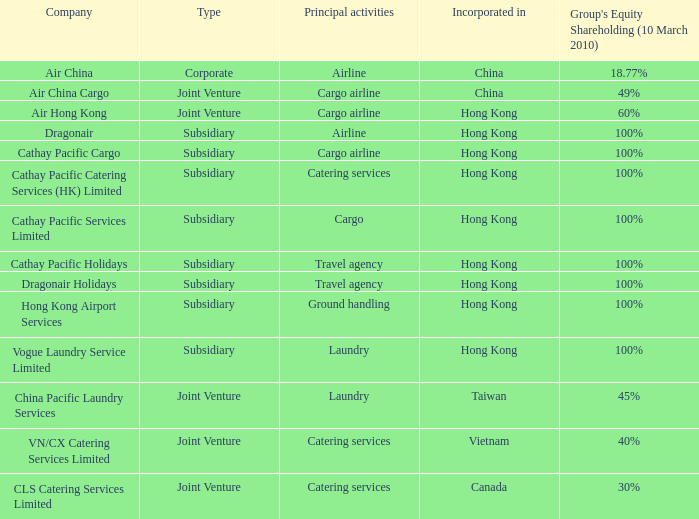Which  company's type is joint venture, and has principle activities listed as Cargo Airline and an incorporation of China? Air China Cargo. Parse the table in full. {'header': ['Company', 'Type', 'Principal activities', 'Incorporated in', "Group's Equity Shareholding (10 March 2010)"], 'rows': [['Air China', 'Corporate', 'Airline', 'China', '18.77%'], ['Air China Cargo', 'Joint Venture', 'Cargo airline', 'China', '49%'], ['Air Hong Kong', 'Joint Venture', 'Cargo airline', 'Hong Kong', '60%'], ['Dragonair', 'Subsidiary', 'Airline', 'Hong Kong', '100%'], ['Cathay Pacific Cargo', 'Subsidiary', 'Cargo airline', 'Hong Kong', '100%'], ['Cathay Pacific Catering Services (HK) Limited', 'Subsidiary', 'Catering services', 'Hong Kong', '100%'], ['Cathay Pacific Services Limited', 'Subsidiary', 'Cargo', 'Hong Kong', '100%'], ['Cathay Pacific Holidays', 'Subsidiary', 'Travel agency', 'Hong Kong', '100%'], ['Dragonair Holidays', 'Subsidiary', 'Travel agency', 'Hong Kong', '100%'], ['Hong Kong Airport Services', 'Subsidiary', 'Ground handling', 'Hong Kong', '100%'], ['Vogue Laundry Service Limited', 'Subsidiary', 'Laundry', 'Hong Kong', '100%'], ['China Pacific Laundry Services', 'Joint Venture', 'Laundry', 'Taiwan', '45%'], ['VN/CX Catering Services Limited', 'Joint Venture', 'Catering services', 'Vietnam', '40%'], ['CLS Catering Services Limited', 'Joint Venture', 'Catering services', 'Canada', '30%']]} 